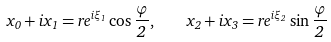Convert formula to latex. <formula><loc_0><loc_0><loc_500><loc_500>x _ { 0 } + i x _ { 1 } = r e ^ { i \xi _ { 1 } } \cos \frac { \varphi } { 2 } , \quad x _ { 2 } + i x _ { 3 } = r e ^ { i \xi _ { 2 } } \sin \frac { \varphi } { 2 }</formula> 